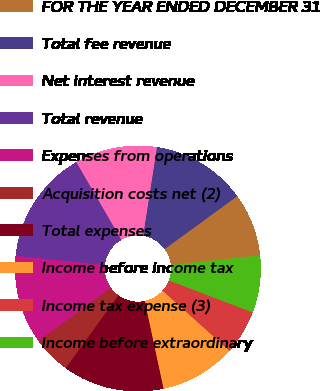<chart> <loc_0><loc_0><loc_500><loc_500><pie_chart><fcel>FOR THE YEAR ENDED DECEMBER 31<fcel>Total fee revenue<fcel>Net interest revenue<fcel>Total revenue<fcel>Expenses from operations<fcel>Acquisition costs net (2)<fcel>Total expenses<fcel>Income before income tax<fcel>Income tax expense (3)<fcel>Income before extraordinary<nl><fcel>8.33%<fcel>12.5%<fcel>10.83%<fcel>15.0%<fcel>11.67%<fcel>5.0%<fcel>13.33%<fcel>10.0%<fcel>5.83%<fcel>7.5%<nl></chart> 